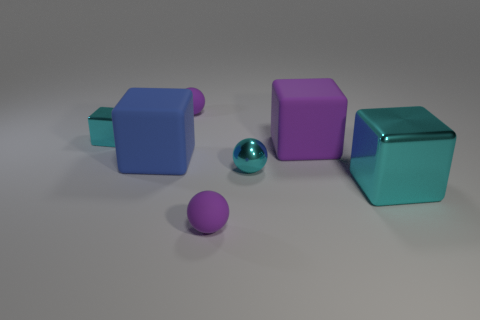Are there any tiny cyan things of the same shape as the large purple rubber thing?
Keep it short and to the point. Yes. There is a metallic thing that is the same size as the cyan shiny ball; what shape is it?
Ensure brevity in your answer.  Cube. Are there the same number of big purple rubber things that are behind the purple matte cube and metal cubes on the left side of the blue matte object?
Ensure brevity in your answer.  No. There is a cyan metallic block that is to the right of the purple sphere behind the tiny metallic cube; what is its size?
Your response must be concise. Large. Is there a yellow matte cylinder that has the same size as the blue matte object?
Give a very brief answer. No. There is another big block that is made of the same material as the purple cube; what is its color?
Your answer should be very brief. Blue. Is the number of blue things less than the number of small cyan metal things?
Your response must be concise. Yes. What material is the cube that is both on the right side of the small cyan metallic ball and behind the blue thing?
Your answer should be very brief. Rubber. There is a shiny block behind the blue thing; are there any large cyan things that are to the left of it?
Provide a short and direct response. No. What number of big metallic cubes are the same color as the tiny block?
Your response must be concise. 1. 